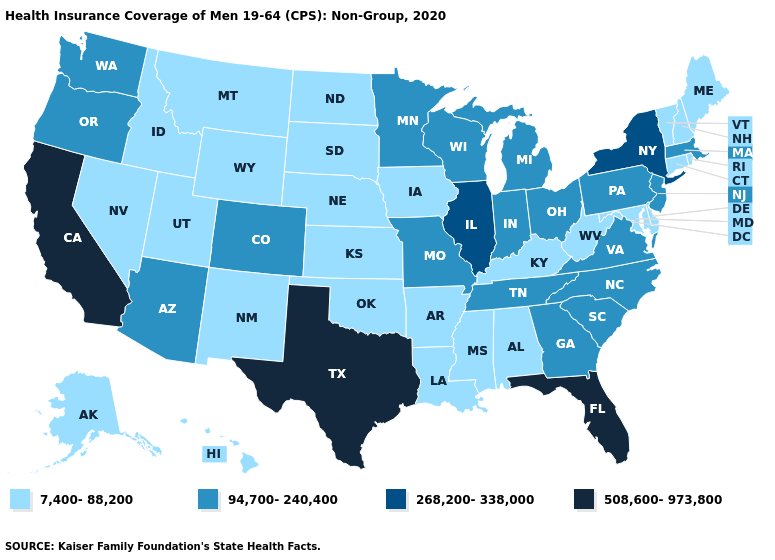What is the value of Vermont?
Give a very brief answer. 7,400-88,200. Does South Carolina have a higher value than North Carolina?
Keep it brief. No. What is the lowest value in the Northeast?
Be succinct. 7,400-88,200. Does Illinois have the highest value in the MidWest?
Concise answer only. Yes. What is the highest value in states that border Texas?
Write a very short answer. 7,400-88,200. Does Virginia have the lowest value in the USA?
Write a very short answer. No. Name the states that have a value in the range 268,200-338,000?
Quick response, please. Illinois, New York. Which states have the highest value in the USA?
Answer briefly. California, Florida, Texas. Among the states that border Mississippi , does Arkansas have the lowest value?
Concise answer only. Yes. Among the states that border Virginia , does Tennessee have the lowest value?
Answer briefly. No. Which states have the highest value in the USA?
Short answer required. California, Florida, Texas. Which states hav the highest value in the South?
Give a very brief answer. Florida, Texas. Does Missouri have a lower value than Arizona?
Give a very brief answer. No. What is the value of Virginia?
Concise answer only. 94,700-240,400. What is the value of Louisiana?
Concise answer only. 7,400-88,200. 